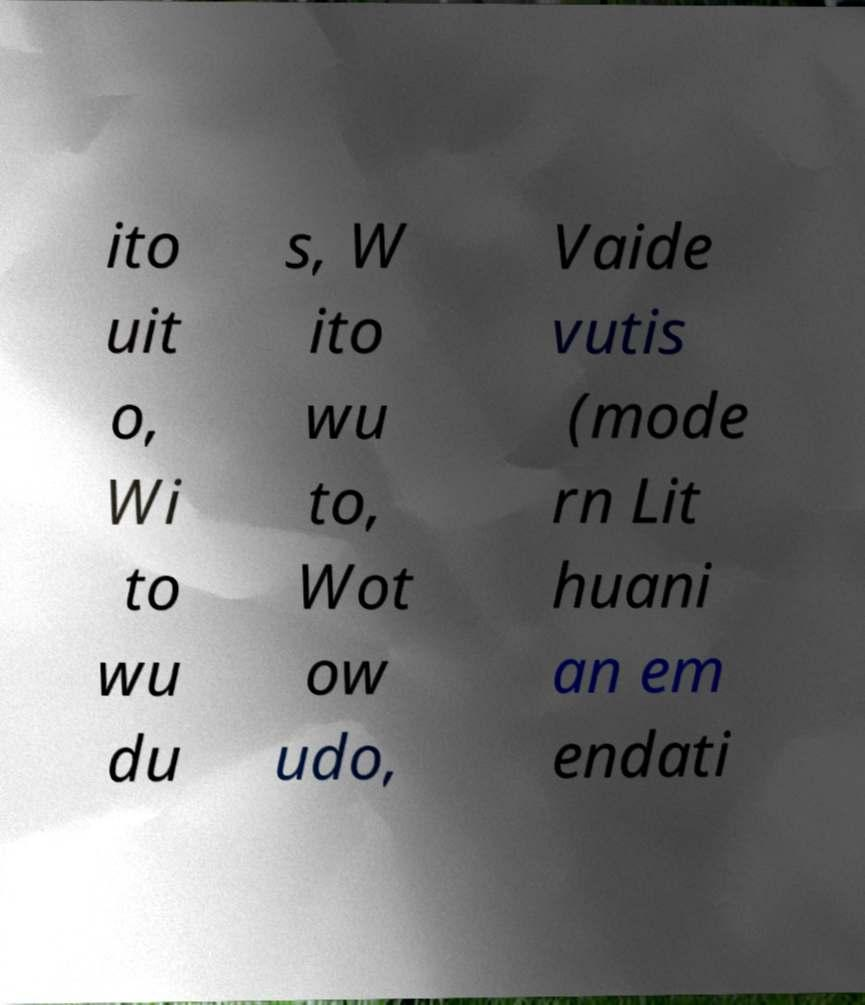Can you accurately transcribe the text from the provided image for me? ito uit o, Wi to wu du s, W ito wu to, Wot ow udo, Vaide vutis (mode rn Lit huani an em endati 